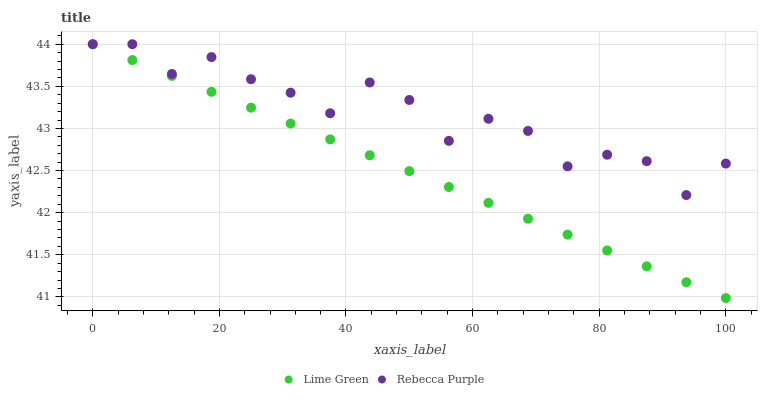Does Lime Green have the minimum area under the curve?
Answer yes or no. Yes. Does Rebecca Purple have the maximum area under the curve?
Answer yes or no. Yes. Does Rebecca Purple have the minimum area under the curve?
Answer yes or no. No. Is Lime Green the smoothest?
Answer yes or no. Yes. Is Rebecca Purple the roughest?
Answer yes or no. Yes. Is Rebecca Purple the smoothest?
Answer yes or no. No. Does Lime Green have the lowest value?
Answer yes or no. Yes. Does Rebecca Purple have the lowest value?
Answer yes or no. No. Does Rebecca Purple have the highest value?
Answer yes or no. Yes. Does Rebecca Purple intersect Lime Green?
Answer yes or no. Yes. Is Rebecca Purple less than Lime Green?
Answer yes or no. No. Is Rebecca Purple greater than Lime Green?
Answer yes or no. No. 